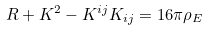Convert formula to latex. <formula><loc_0><loc_0><loc_500><loc_500>R + K ^ { 2 } - K ^ { i j } K _ { i j } = 1 6 \pi \rho _ { E }</formula> 